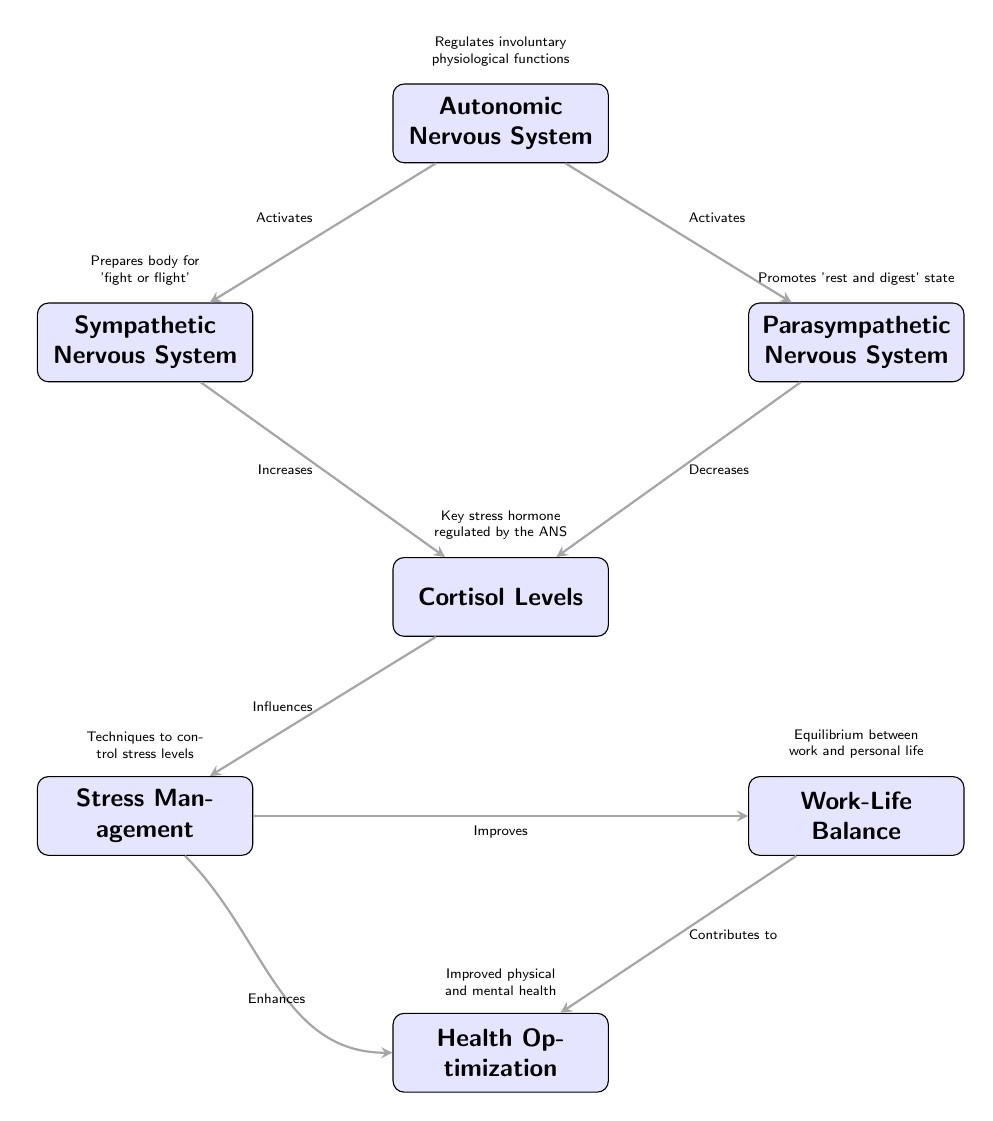What is the main regulatory system depicted in the diagram? The main regulatory system shown in the diagram is the Autonomic Nervous System, which is prominently labeled as the central node.
Answer: Autonomic Nervous System How many nodes are present in the diagram? By counting the labeled nodes including the Autonomic Nervous System and its related elements, there are a total of seven nodes.
Answer: Seven What does the sympathetic nervous system primarily prepare the body for? The symmetric nervous system prepares the body for 'fight or flight' situations, as indicated next to its label in the diagram.
Answer: Fight or flight What effect does the parasympathetic nervous system have on cortisol levels? The diagram indicates that the parasympathetic nervous system decreases cortisol levels, which is a key stress hormone represented in the flow.
Answer: Decreases How does stress management influence work-life balance according to the diagram? The diagram shows that stress management improves work-life balance, linking these two nodes together to reflect this relationship.
Answer: Improves What is the relationship between cortisol levels and stress management? Cortisol levels influence stress management as depicted by the directed edge connecting the two; increased cortisol typically suggests a stressor influence.
Answer: Influences Which element contributes to health optimization from work-life balance? The diagram shows that work-life balance contributes to health optimization, highlighting the positive effect of balance on overall health.
Answer: Contributes to What technique is mentioned as a way to control stress levels? The node labeled 'Stress Management' encompasses various techniques aimed at controlling stress levels, conceptualizing this as a broad category.
Answer: Techniques How does stress management enhance health optimization? The diagram illustrates a feedback loop indicating that stress management enhances health optimization, suggesting that by managing stress, one can improve health.
Answer: Enhances 